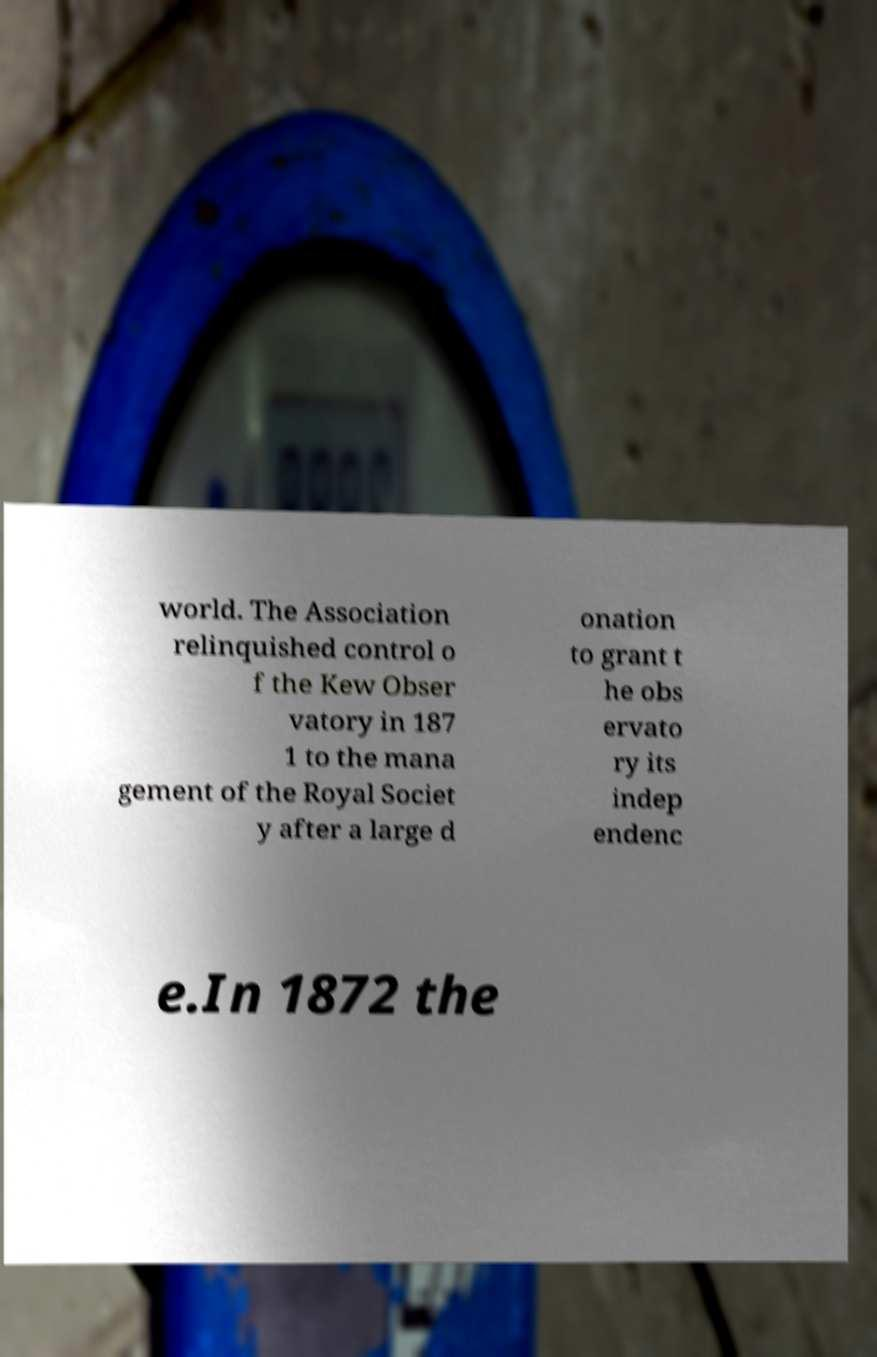Could you extract and type out the text from this image? world. The Association relinquished control o f the Kew Obser vatory in 187 1 to the mana gement of the Royal Societ y after a large d onation to grant t he obs ervato ry its indep endenc e.In 1872 the 